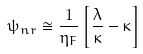<formula> <loc_0><loc_0><loc_500><loc_500>\psi _ { n r } \cong \frac { 1 } { \eta _ { F } } \left [ \frac { \lambda } { \kappa } - \kappa \right ]</formula> 